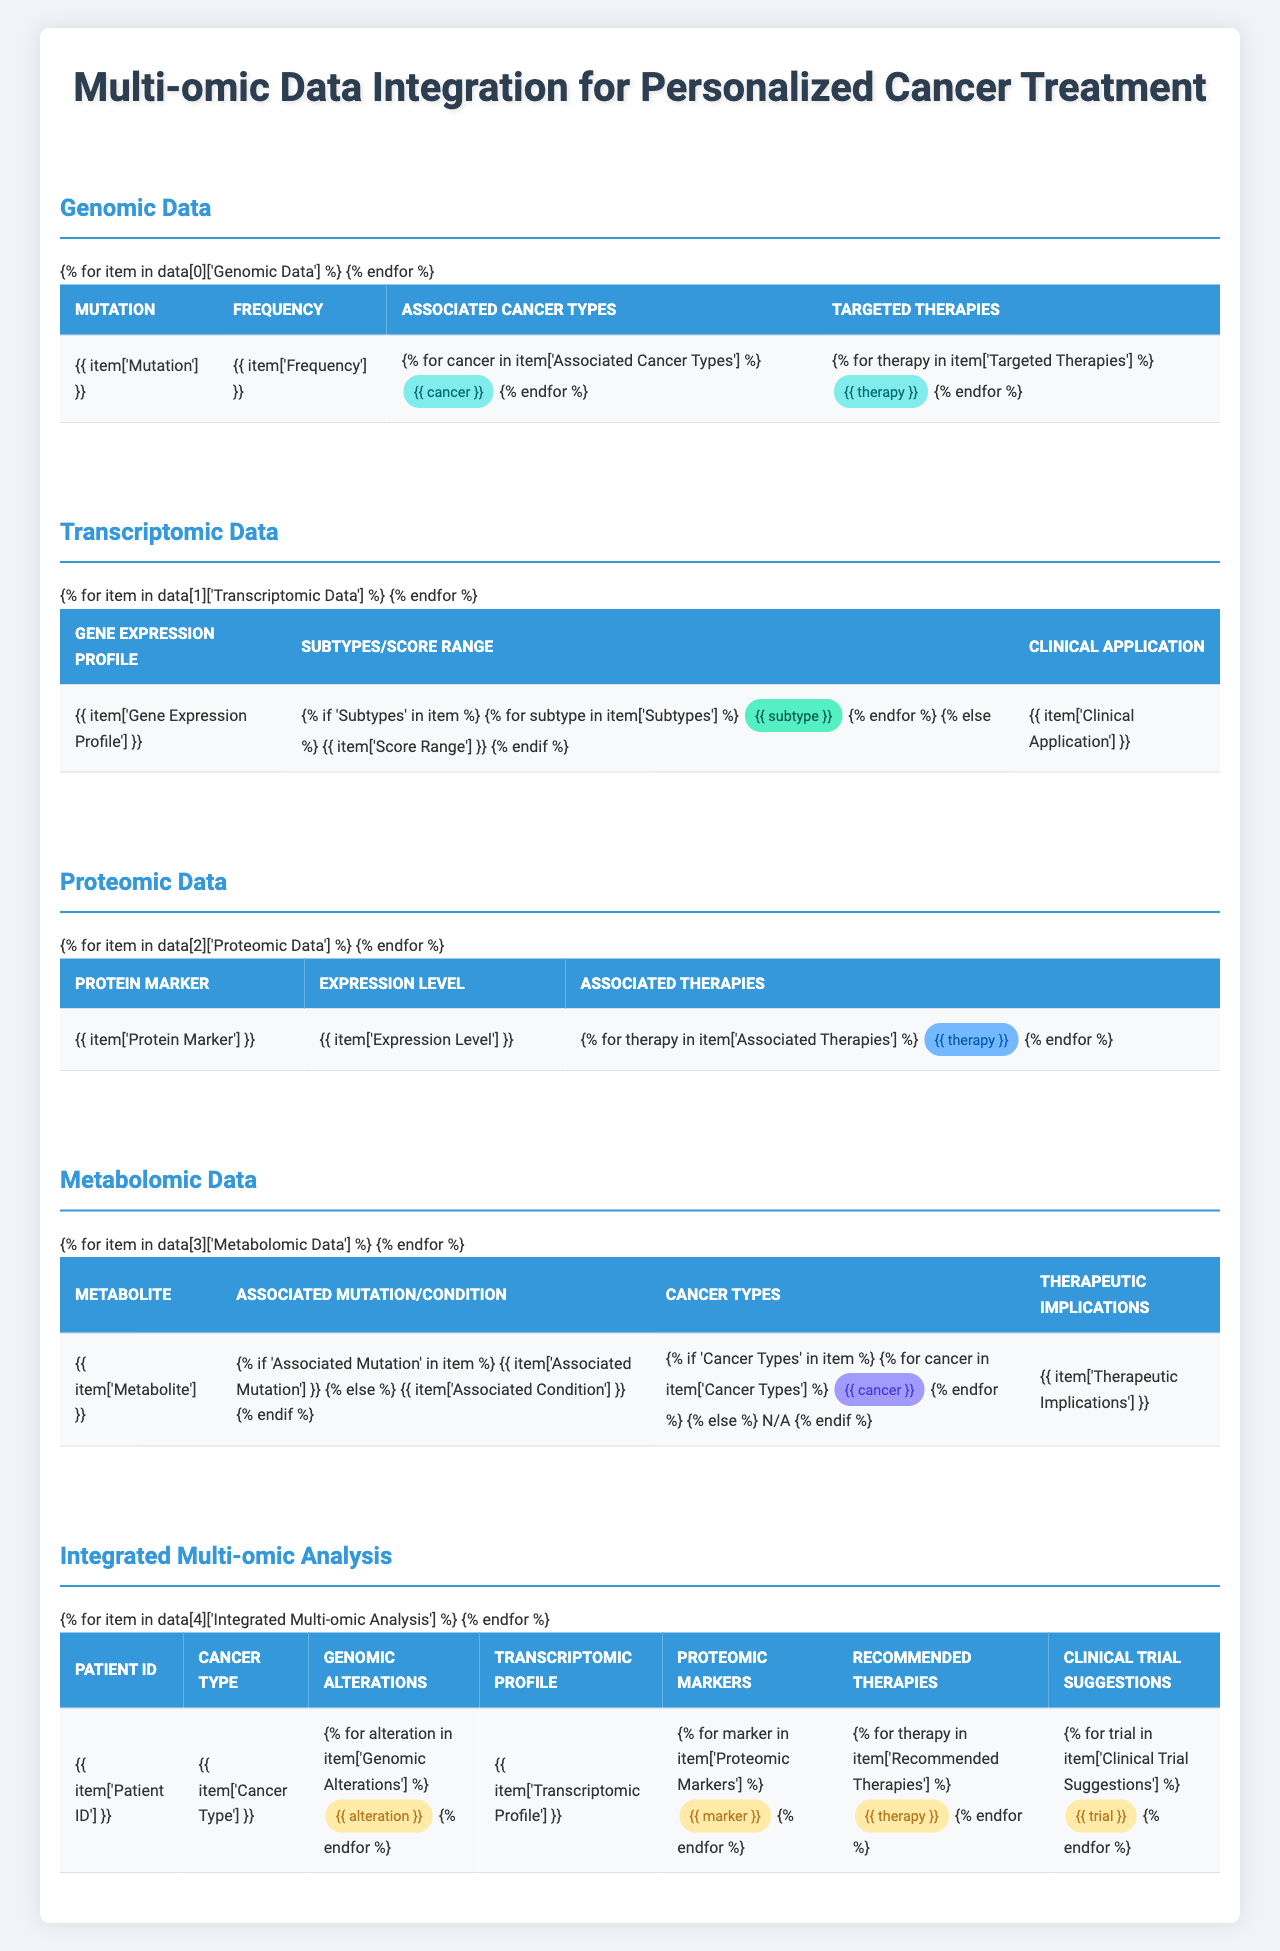What is the associated cancer type for the BRAF V600E mutation? The table lists BRAF V600E's associated cancer types under the genomic data section, specifically stating Melanoma, Colorectal Cancer, and Thyroid Cancer.
Answer: Melanoma, Colorectal Cancer, Thyroid Cancer Which protein marker has a high expression level? In the proteomic data section, PD-L1 is highlighted as having a high expression level, according to the corresponding entry in the table.
Answer: PD-L1 What is the recommended therapy for a patient with a BRCA1 mutation? The integrated multi-omic analysis section mentions that for the patient with a BRCA1 mutation, the recommended therapies are PARP inhibitors and immunotherapy.
Answer: PARP inhibitors, Immunotherapy Is there a transcriptomic profile associated with colorectal cancer? The integrated analysis section shows that the colorectal cancer patient's transcriptomic profile is CMS1 (MSI Immune), confirming there is indeed a profile associated with this type of cancer.
Answer: Yes How many targeted therapies are available for the HER2 amplification mutation? The genomic data lists three targeted therapies for HER2 amplification: Trastuzumab, Pertuzumab, and T-DM1. Therefore, the count is three.
Answer: Three Which cancer types are associated with the metabolite 2-hydroxyglutarate? The metabolomic data indicates that the metabolite 2-hydroxyglutarate is associated with Acute Myeloid Leukemia and Glioma, as noted in the corresponding entry.
Answer: Acute Myeloid Leukemia, Glioma Are there clinical trial suggestions for the patient with colorectal cancer? The integrated multi-omic analysis for the colorectal cancer patient lists two clinical trial suggestions: NCT04044430 and NCT03832621, confirming availability of trials.
Answer: Yes Which gene expression profile is used for breast cancer recurrence risk assessment and what is its score range? The transcriptomic data states that Oncotype DX is used for breast cancer recurrence risk assessment, with a score range of 0-100.
Answer: Oncotype DX, Score Range: 0-100 What is the therapeutic implication of the metabolite sarcosine? According to the metabolomic data, sarcosine is noted to serve as a biomarker for monitoring disease progression in prostate cancer.
Answer: Biomarker for disease monitoring Which patient has a high PD-L1 expression and what is the cancer type? The integrated multi-omic analysis identifies patient TCGA-BR-4253, who has a high PD-L1 expression, and the cancer type listed is Triple-Negative Breast Cancer.
Answer: TCGA-BR-4253, Triple-Negative Breast Cancer 